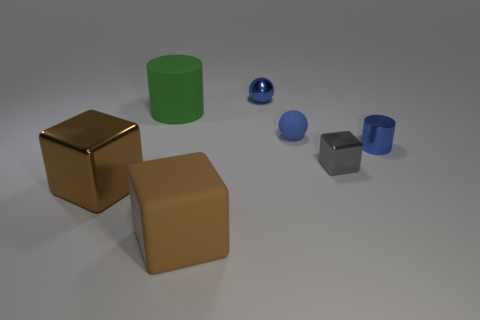Subtract all big blocks. How many blocks are left? 1 Add 2 purple cylinders. How many objects exist? 9 Subtract all gray blocks. How many blocks are left? 2 Subtract all purple cylinders. How many gray blocks are left? 1 Add 6 small gray blocks. How many small gray blocks exist? 7 Subtract 0 yellow cylinders. How many objects are left? 7 Subtract all cylinders. How many objects are left? 5 Subtract 2 cylinders. How many cylinders are left? 0 Subtract all purple cylinders. Subtract all brown spheres. How many cylinders are left? 2 Subtract all small metal cylinders. Subtract all large yellow rubber blocks. How many objects are left? 6 